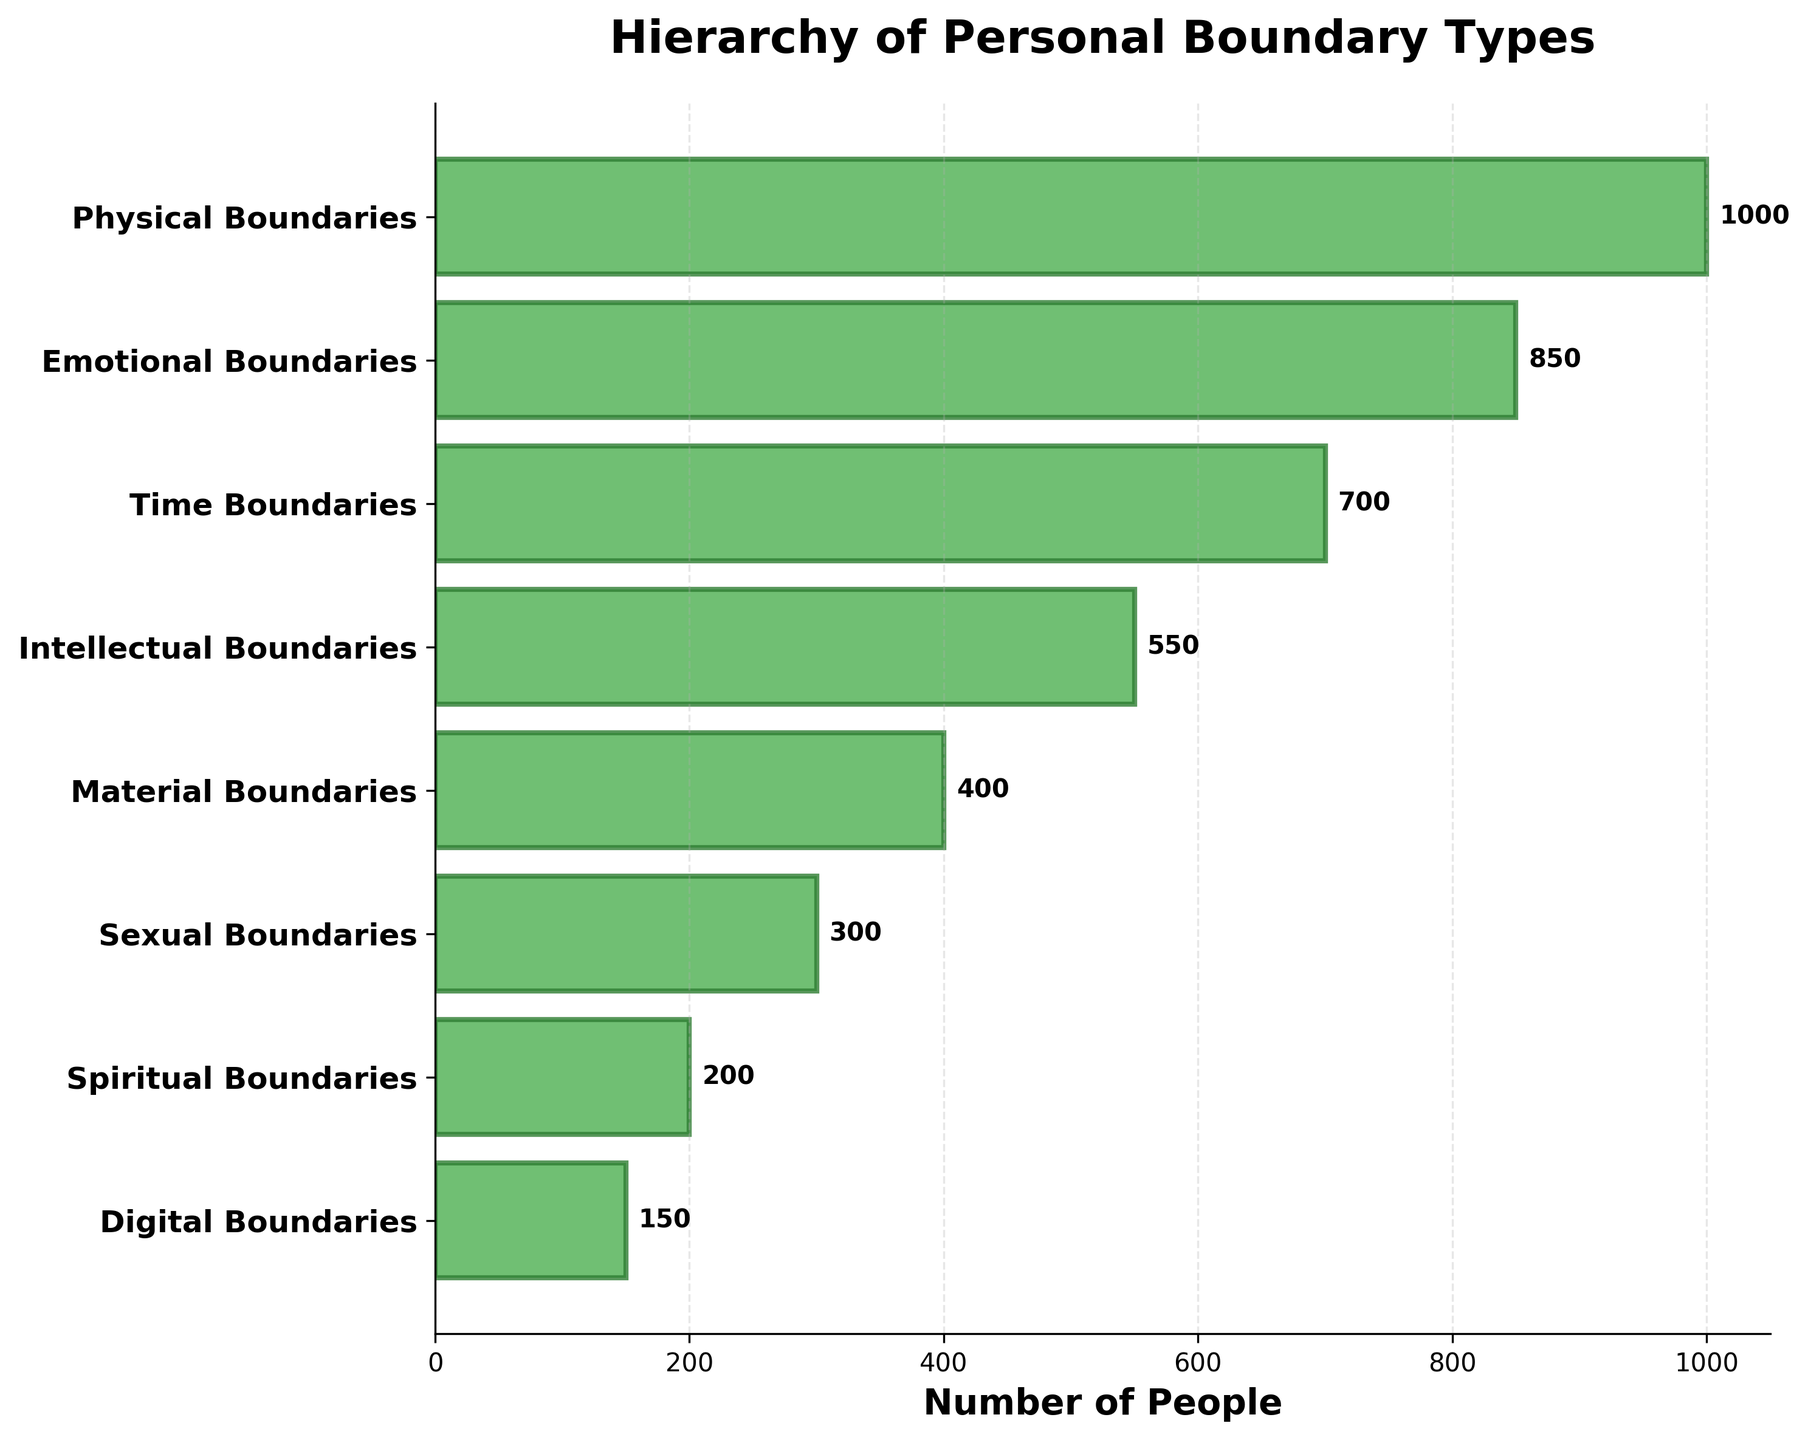What's the title of the funnel chart? The title of the funnel chart is typically displayed at the top of the chart. In this case, it reads "Hierarchy of Personal Boundary Types".
Answer: Hierarchy of Personal Boundary Types How many stages are presented in the funnel chart? The stages are listed along the y-axis of the funnel chart. Counting them gives us the total number of stages.
Answer: 8 Which boundary type has the highest number of people? The longest bar represents the boundary type with the highest number of people, which is labeled as "Physical Boundaries".
Answer: Physical Boundaries What is the number of people associated with Spiritual Boundaries? The number next to the bar labeled "Spiritual Boundaries" shows the number of people, which is 200.
Answer: 200 How many more people are there in Emotional Boundaries compared to Sexual Boundaries? The number of people in Emotional Boundaries is 850, and in Sexual Boundaries is 300. Subtracting these gives us the difference: 850 - 300 = 550.
Answer: 550 What is the sum of people categorized under Intellectual and Material Boundaries? The number of people in Intellectual Boundaries is 550, and in Material Boundaries is 400. Adding these together gives us 550 + 400 = 950.
Answer: 950 Which boundary type has the second lowest number of people? By examining the lengths of the bars and reading their labels, we can see that "Digital Boundaries" has the second lowest number of people (150).
Answer: Digital Boundaries How many boundary types have more than 500 people associated with them? By looking at the values in each bar, we see that "Physical Boundaries" (1000), "Emotional Boundaries" (850), and "Time Boundaries" (700) are all above 500. Therefore, there are 3 boundary types with more than 500 people.
Answer: 3 What's the difference in the number of people between the most and least flexible boundary types? The most rigid boundary type is "Physical Boundaries" with 1000 people, and the most flexible boundary type is "Digital Boundaries" with 150 people. The difference is calculated as 1000 - 150 = 850.
Answer: 850 Calculate the average number of people across all boundary types. Adding the number of people for all boundary types gives us 1000 + 850 + 700 + 550 + 400 + 300 + 200 + 150 = 4150. There are 8 boundary types, so the average is 4150 / 8 = 518.75.
Answer: 518.75 